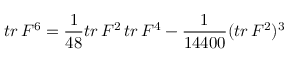<formula> <loc_0><loc_0><loc_500><loc_500>t r \, F ^ { 6 } = \frac { 1 } { 4 8 } t r \, F ^ { 2 } \, t r \, F ^ { 4 } - \frac { 1 } { 1 4 4 0 0 } ( t r \, F ^ { 2 } ) ^ { 3 }</formula> 